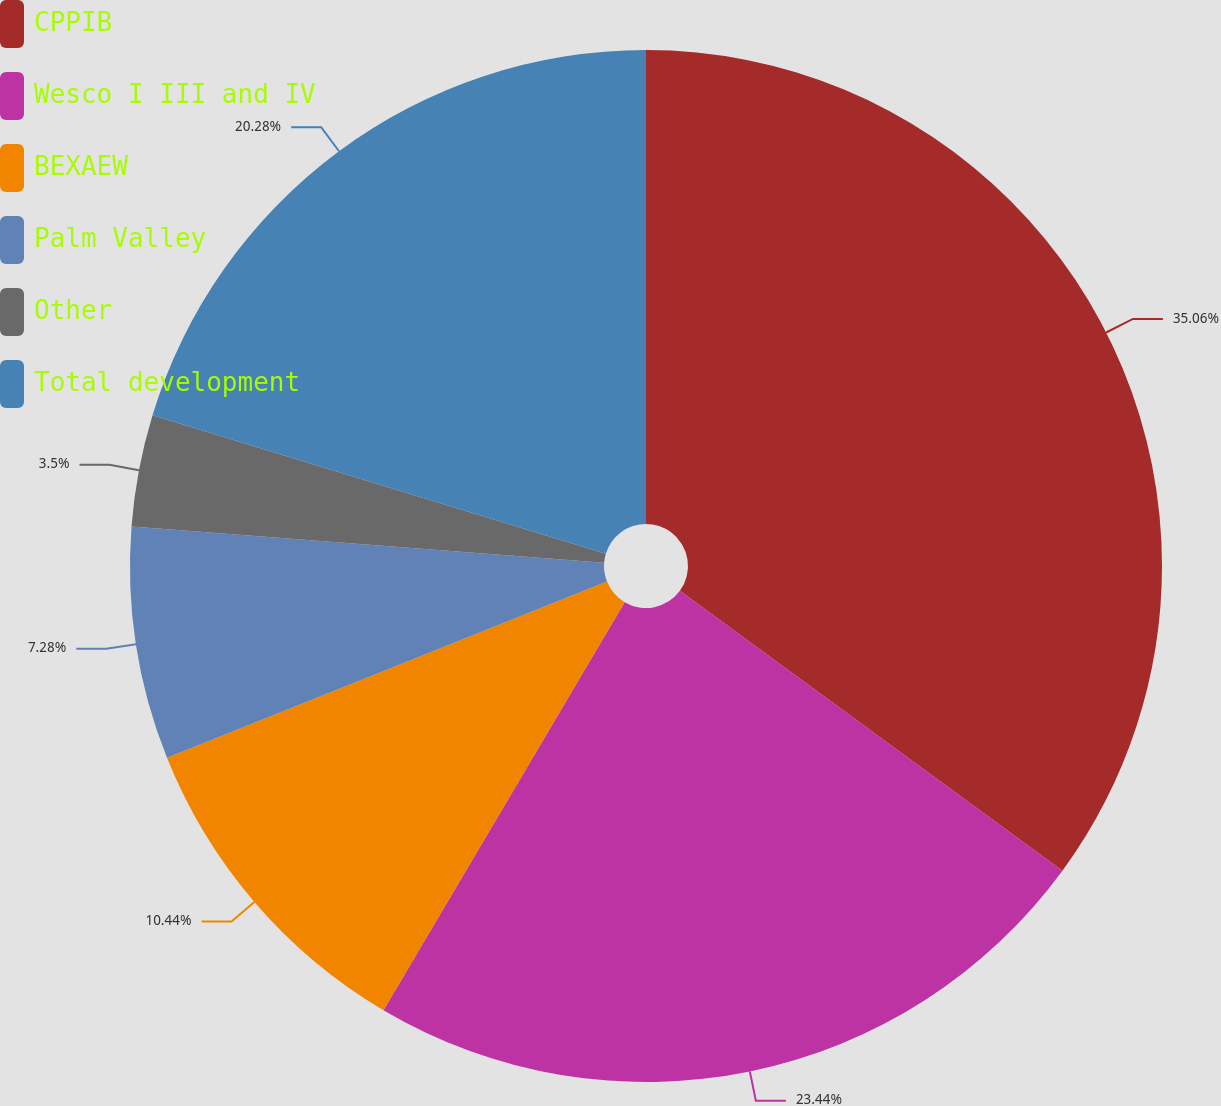Convert chart. <chart><loc_0><loc_0><loc_500><loc_500><pie_chart><fcel>CPPIB<fcel>Wesco I III and IV<fcel>BEXAEW<fcel>Palm Valley<fcel>Other<fcel>Total development<nl><fcel>35.05%<fcel>23.44%<fcel>10.44%<fcel>7.28%<fcel>3.5%<fcel>20.28%<nl></chart> 